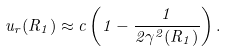<formula> <loc_0><loc_0><loc_500><loc_500>u _ { r } ( R _ { 1 } ) \approx c \left ( 1 - \frac { 1 } { 2 \gamma ^ { 2 } ( R _ { 1 } ) } \right ) .</formula> 